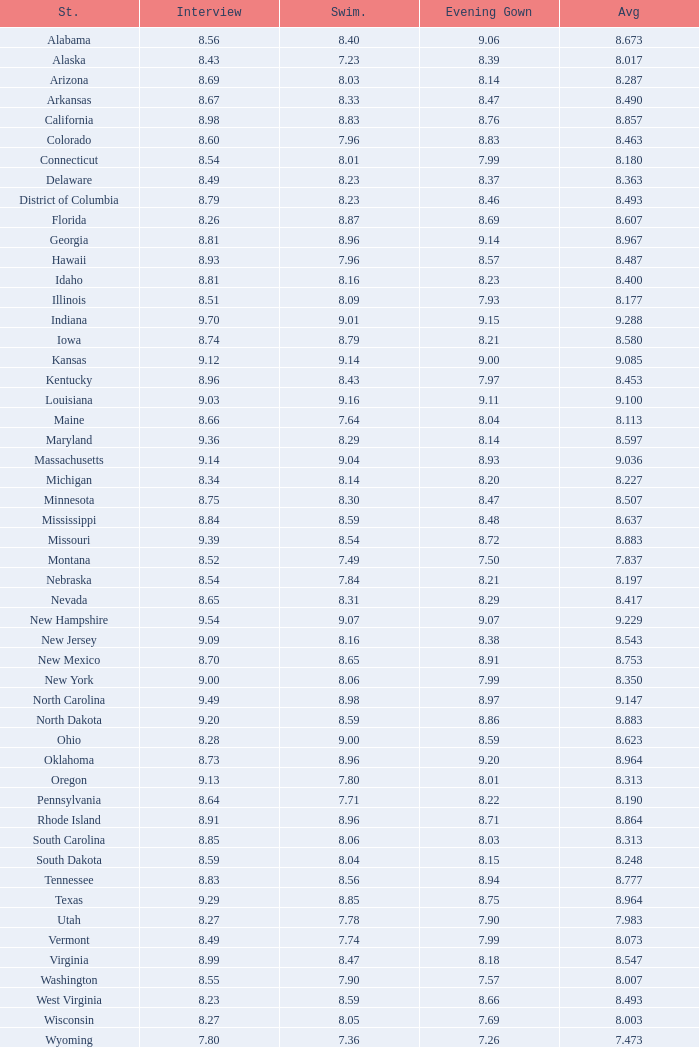Name the state with an evening gown more than 8.86 and interview less than 8.7 and swimsuit less than 8.96 Alabama. 